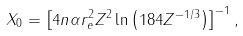Convert formula to latex. <formula><loc_0><loc_0><loc_500><loc_500>X _ { 0 } = \left [ 4 n \alpha r _ { e } ^ { 2 } Z ^ { 2 } \ln \left ( 1 8 4 Z ^ { - 1 / 3 } \right ) \right ] ^ { - 1 } ,</formula> 